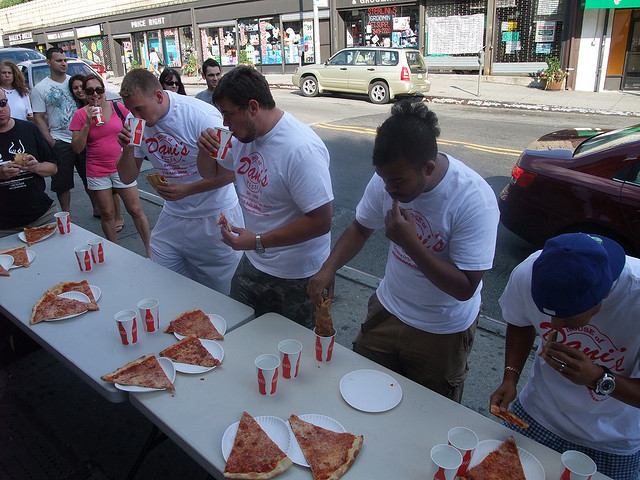<image>Who will finish the contest first? It is unknown who will finish the contest first. It could be the man in the blue hat, the man to the right, the second man to the right, the last man on the left, or the second person. Who will finish the contest first? I am not sure who will finish the contest first. It can be any of the people mentioned. 